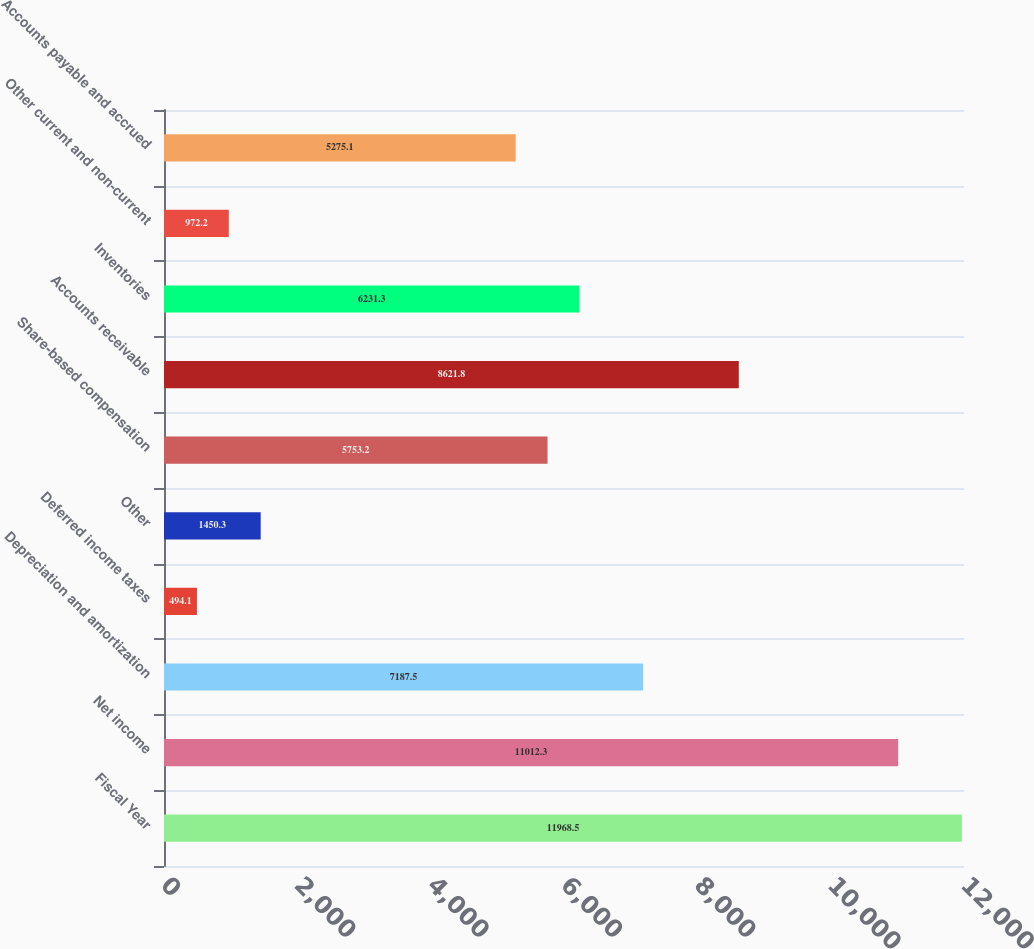<chart> <loc_0><loc_0><loc_500><loc_500><bar_chart><fcel>Fiscal Year<fcel>Net income<fcel>Depreciation and amortization<fcel>Deferred income taxes<fcel>Other<fcel>Share-based compensation<fcel>Accounts receivable<fcel>Inventories<fcel>Other current and non-current<fcel>Accounts payable and accrued<nl><fcel>11968.5<fcel>11012.3<fcel>7187.5<fcel>494.1<fcel>1450.3<fcel>5753.2<fcel>8621.8<fcel>6231.3<fcel>972.2<fcel>5275.1<nl></chart> 